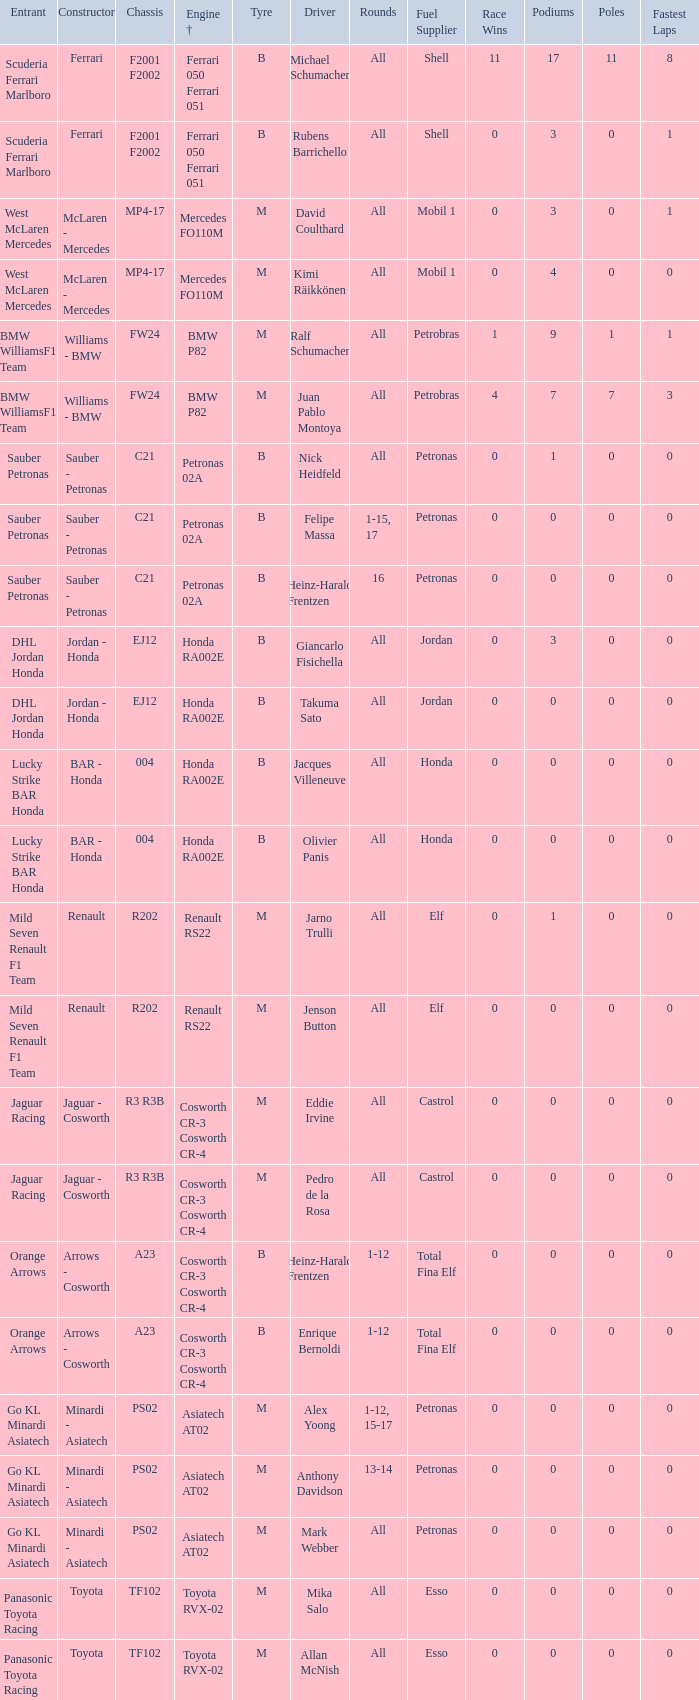Who is the entrant when the engine is bmw p82? BMW WilliamsF1 Team, BMW WilliamsF1 Team. 